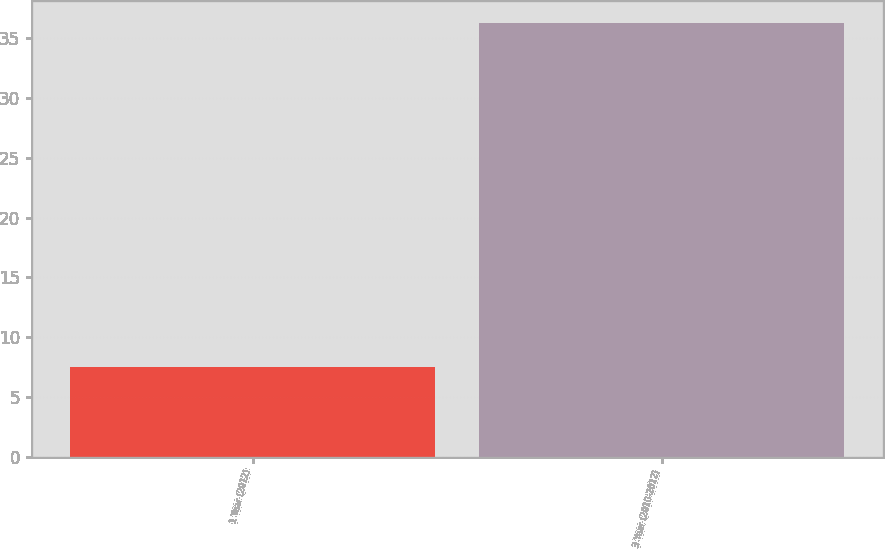Convert chart. <chart><loc_0><loc_0><loc_500><loc_500><bar_chart><fcel>1 Year (2012)<fcel>3 Year (2010-2012)<nl><fcel>7.5<fcel>36.3<nl></chart> 